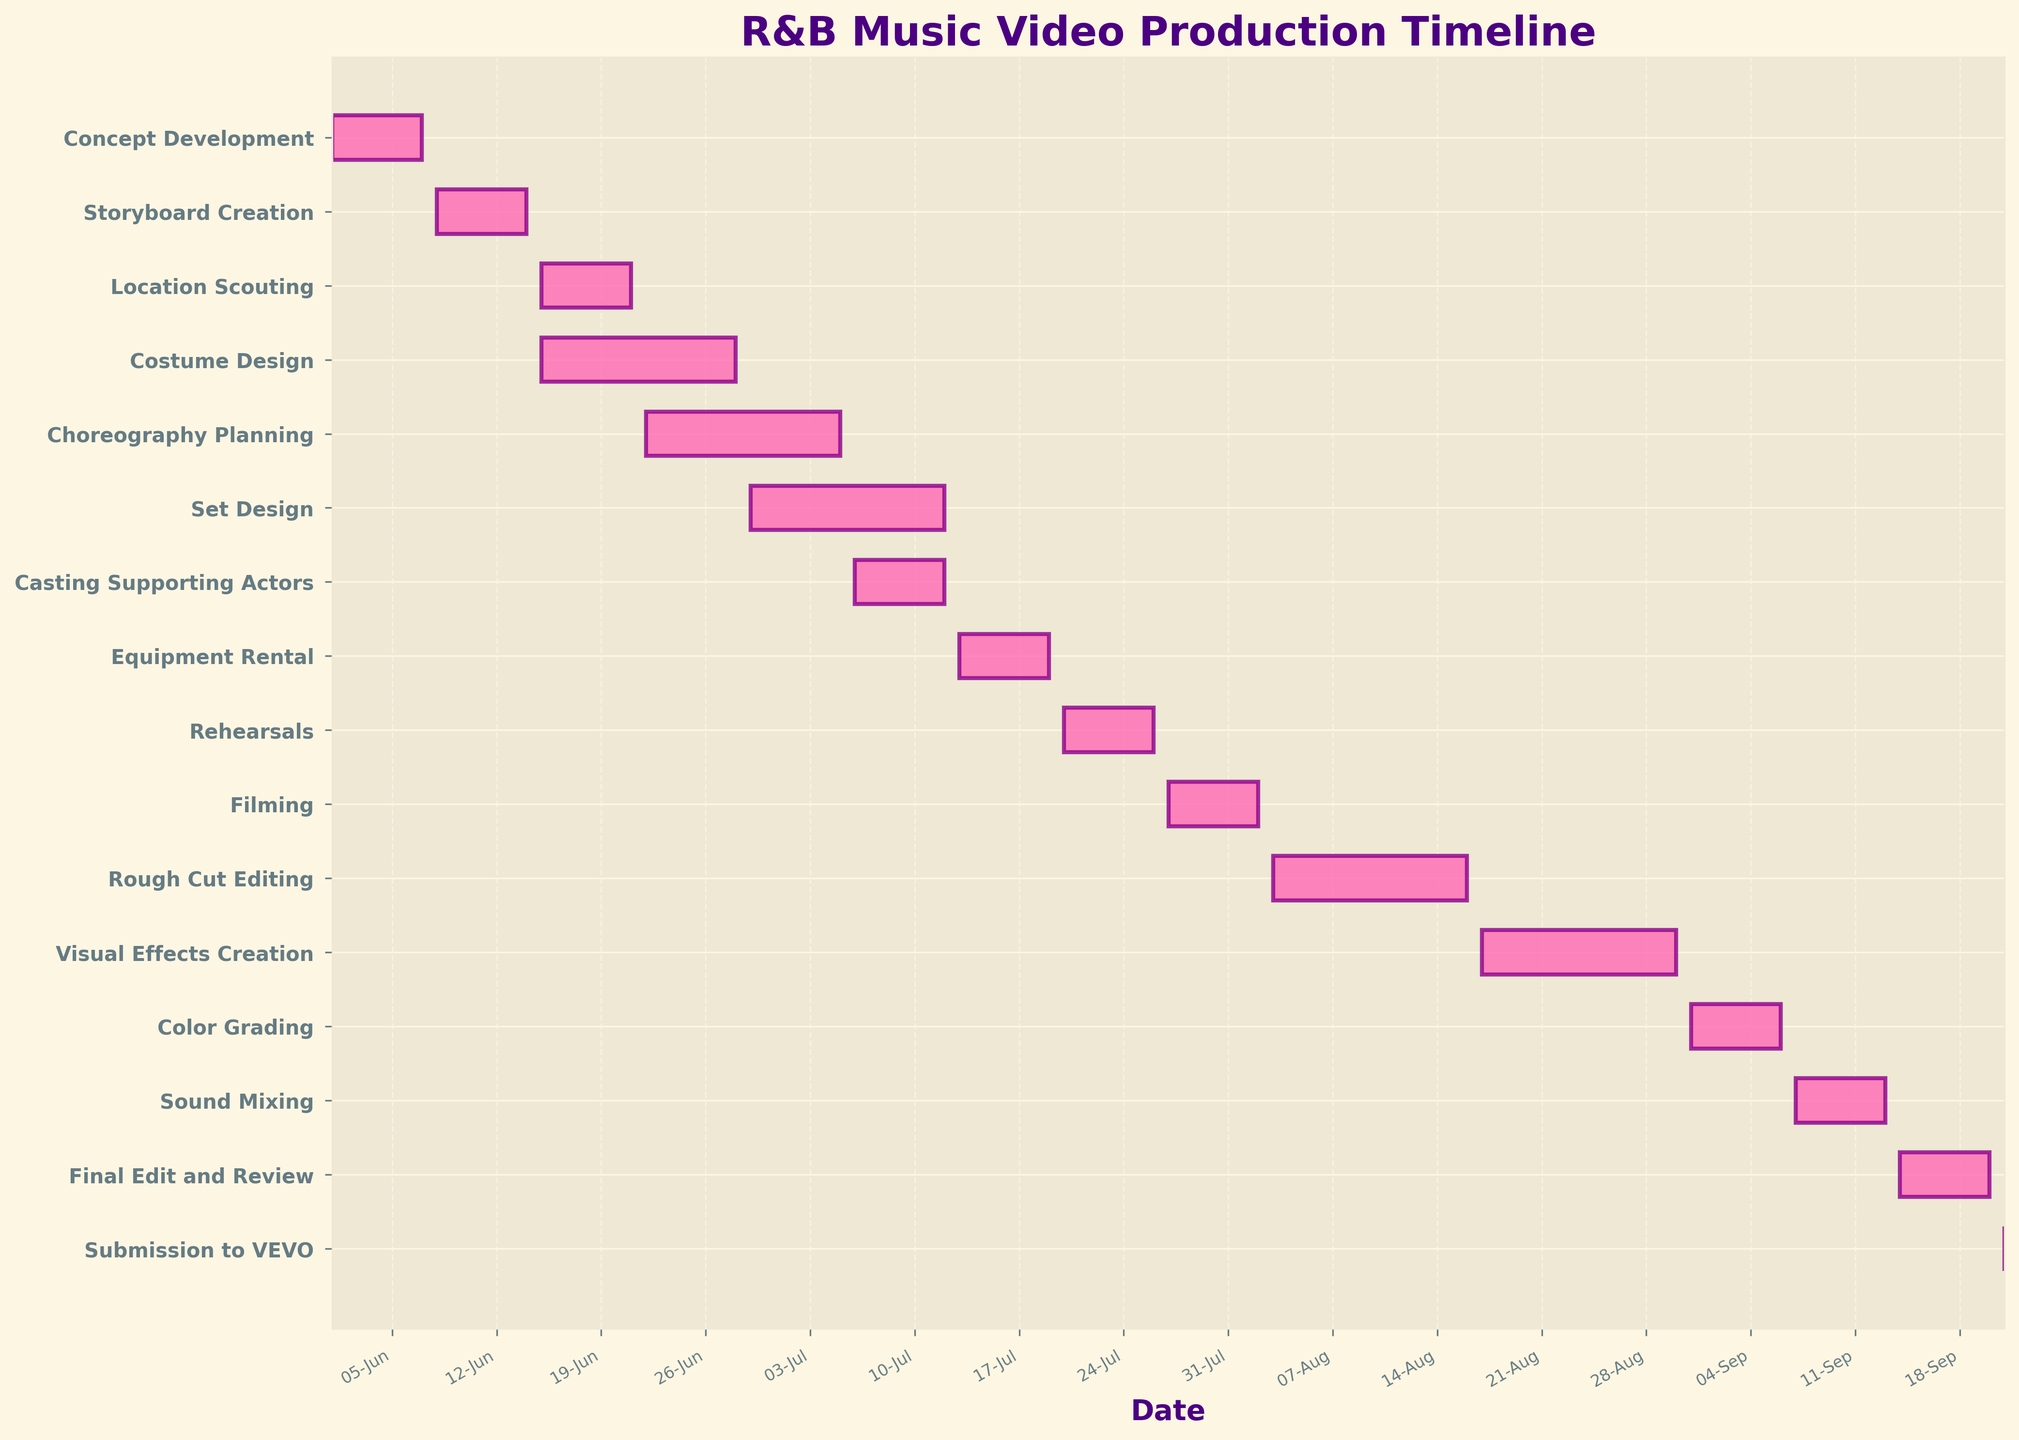What's the title of the figure? The question asks for the title of the chart. By looking at the top part of the figure, we can see the text that serves as the title.
Answer: R&B Music Video Production Timeline What is the start date for Concept Development? This question seeks the starting point of the "Concept Development" task. By locating "Concept Development" on the y-axis and following the horizontal bar to the left, we can find the start date.
Answer: 2023-06-01 How many tasks run concurrently with Costume Design? To answer this, identify the timeline of "Costume Design" and then see how many other tasks overlap in this timeframe. "Costume Design" runs from 2023-06-15 to 2023-06-28. "Location Scouting" (2023-06-15 to 2023-06-21) overlaps in this period.
Answer: 1 What is the total duration from the start of "Concept Development" to the end of "Final Edit and Review"? Calculate the difference in days between the start of "Concept Development" (2023-06-01) and the end of "Final Edit and Review" (2023-09-20).
Answer: 111 days Which task is scheduled right before "Filming"? Look at the task that ends just before the start of "Filming." "Rehearsals" finishes on 2023-07-26, while "Filming" starts on 2023-07-27.
Answer: Rehearsals During what dates does "Visual Effects Creation" take place? Identify the timeline of the "Visual Effects Creation" task by looking at its horizontal bar and noting the start and end dates.
Answer: 2023-08-17 to 2023-08-30 Which task has the shortest duration, and what is it? Find the task whose bar length is the shortest by looking at the figure. "Submission to VEVO" lasts only one day (2023-09-21).
Answer: Submission to VEVO How long is the editing phase, including Rough Cut Editing, Visual Effects Creation, Color Grading, Sound Mixing, and Final Edit and Review? Sum the durations of each editing-related task: "Rough Cut Editing" (14 days), "Visual Effects Creation" (14 days), "Color Grading" (7 days), "Sound Mixing" (7 days), "Final Edit and Review" (7 days).
Answer: 49 days What tasks are scheduled to start immediately after "Costume Design" ends? Locate "Costume Design," then find which tasks start right after it ends on 2023-06-28. "Choreography Planning" starts on 2023-06-22 before "Costume Design" ends. However, no tasks start immediately after June 28.
Answer: None Which tasks overlap with "Set Design"? Identify the timeline of "Set Design" (2023-06-29 to 2023-07-12), then see which other tasks have timelines that overlap with these dates. "Choreography Planning" (2023-06-22 to 2023-07-05) and "Casting Supporting Actors" (2023-07-06 to 2023-07-12) overlap in this period.
Answer: Choreography Planning, Casting Supporting Actors 